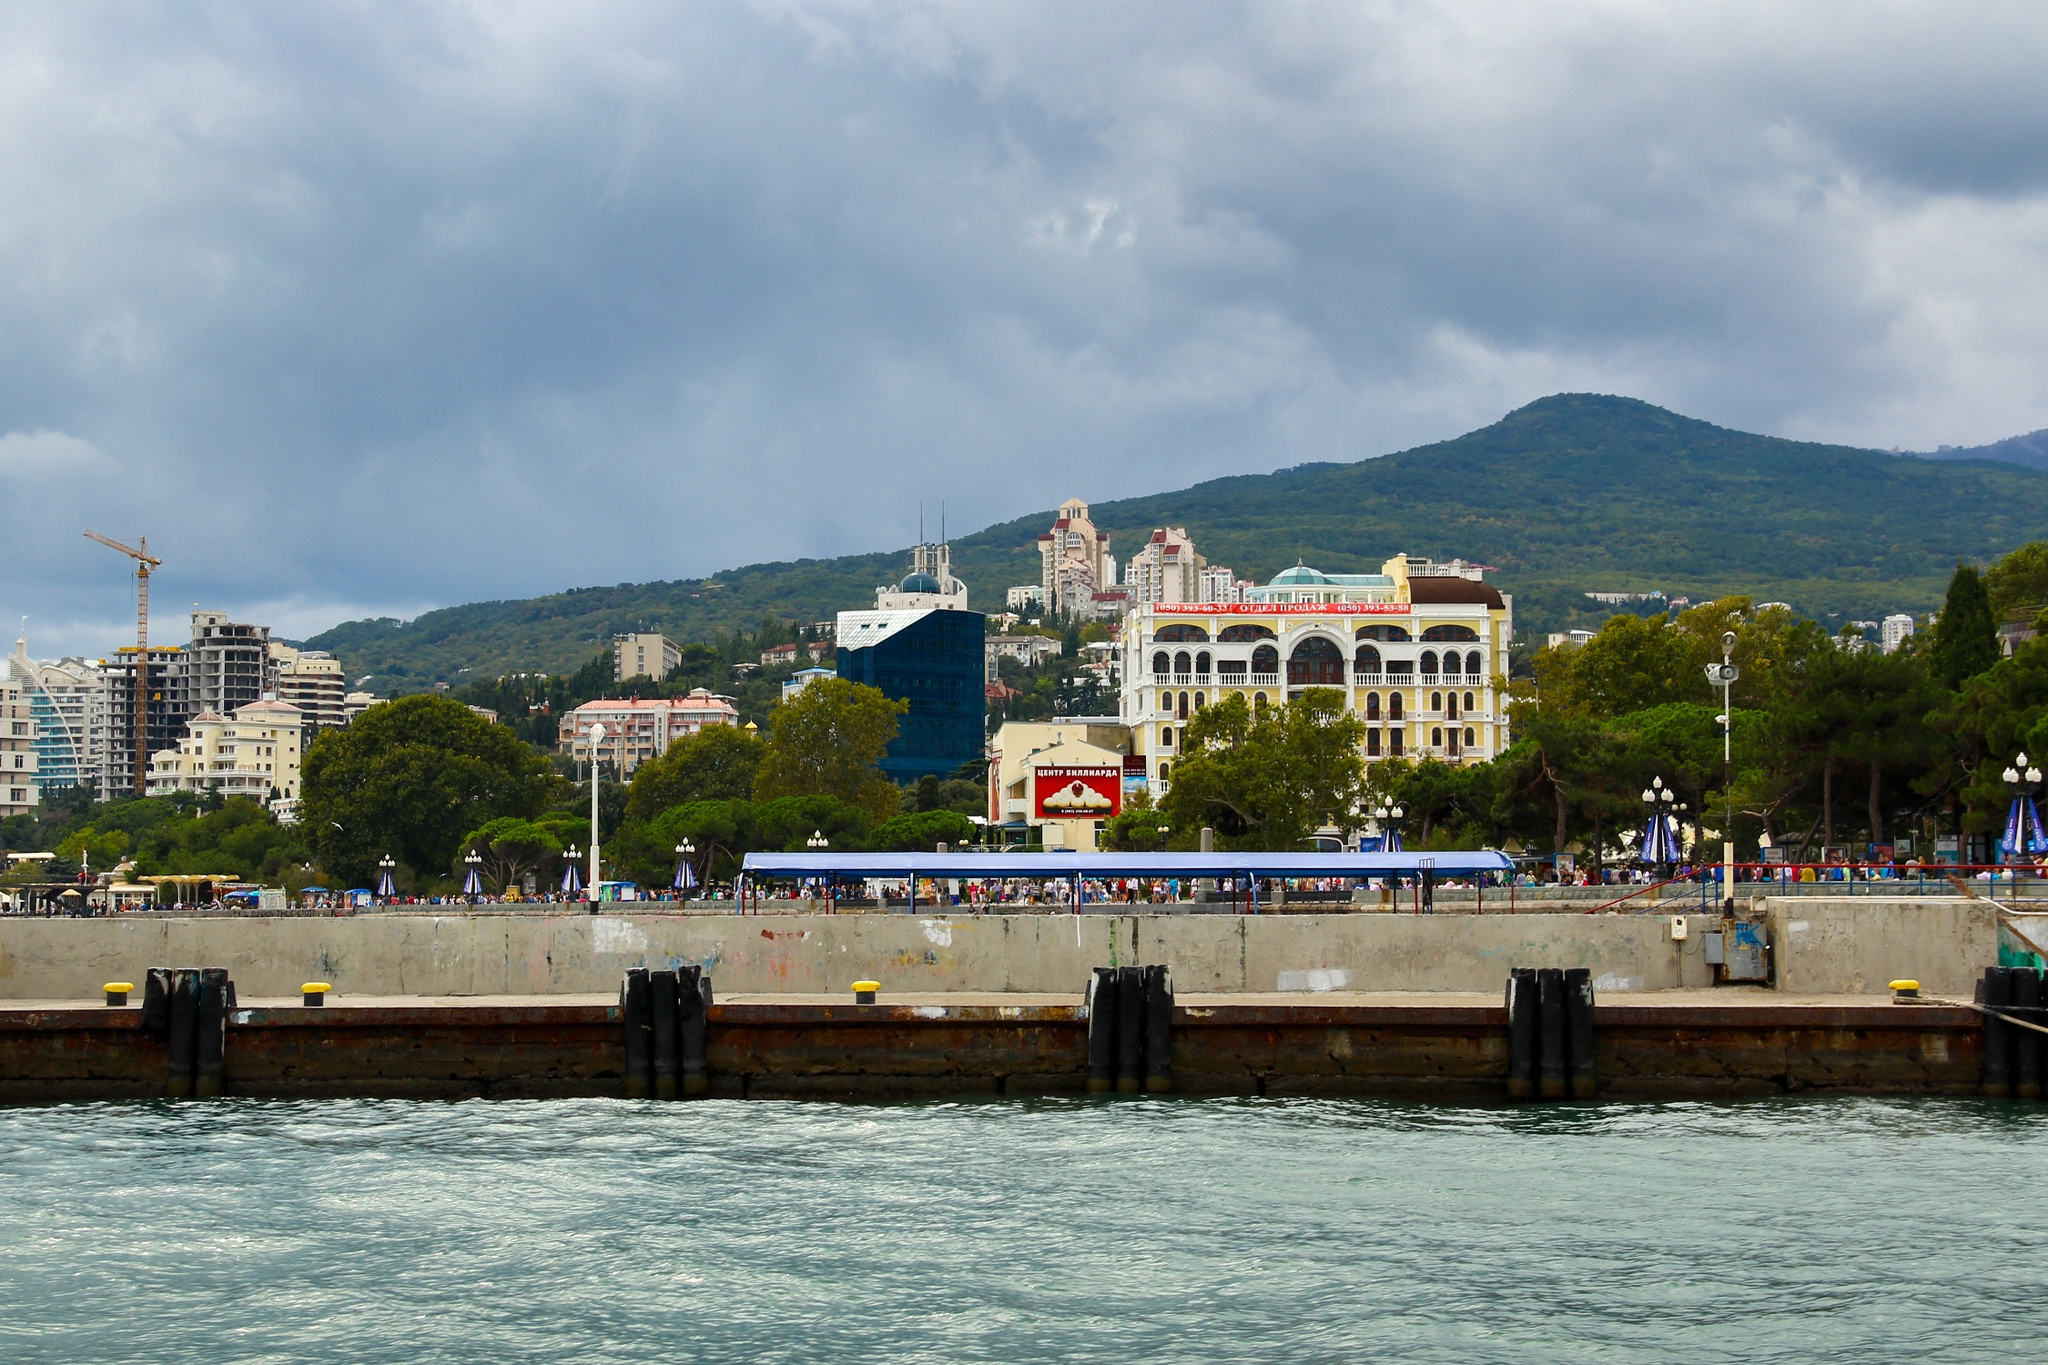Can you provide more details about the buildings in the background? Certainly! The buildings in the background of the image showcase a mix of architectural styles and colors. Prominently, there is a large white building with a bright red roof, standing out against the lush greenery. Next to it, a striking blue building with a green roof catches the eye. These buildings are surrounded by a variety of other structures, ranging from modern high-rises to more traditional designs. The architectural diversity indicates a rich cultural tapestry, blending the historical with the contemporary. This eclectic mix of buildings not only adds visual interest but also reflects the vibrant character of the Yalta seafront. What can we infer about the culture of this place based on the architecture? The varied architecture in the image suggests a rich and multifaceted culture. The blend of modern and historical buildings indicates an area that values both progress and tradition. The grand, ornate structures hint at a storied past and possibly a history of affluence or significance, while the more contemporary buildings signal ongoing development and adaptation. This juxtaposition reflects a community that honors its heritage while embracing the future, illustrating a dynamic and culturally rich environment. 